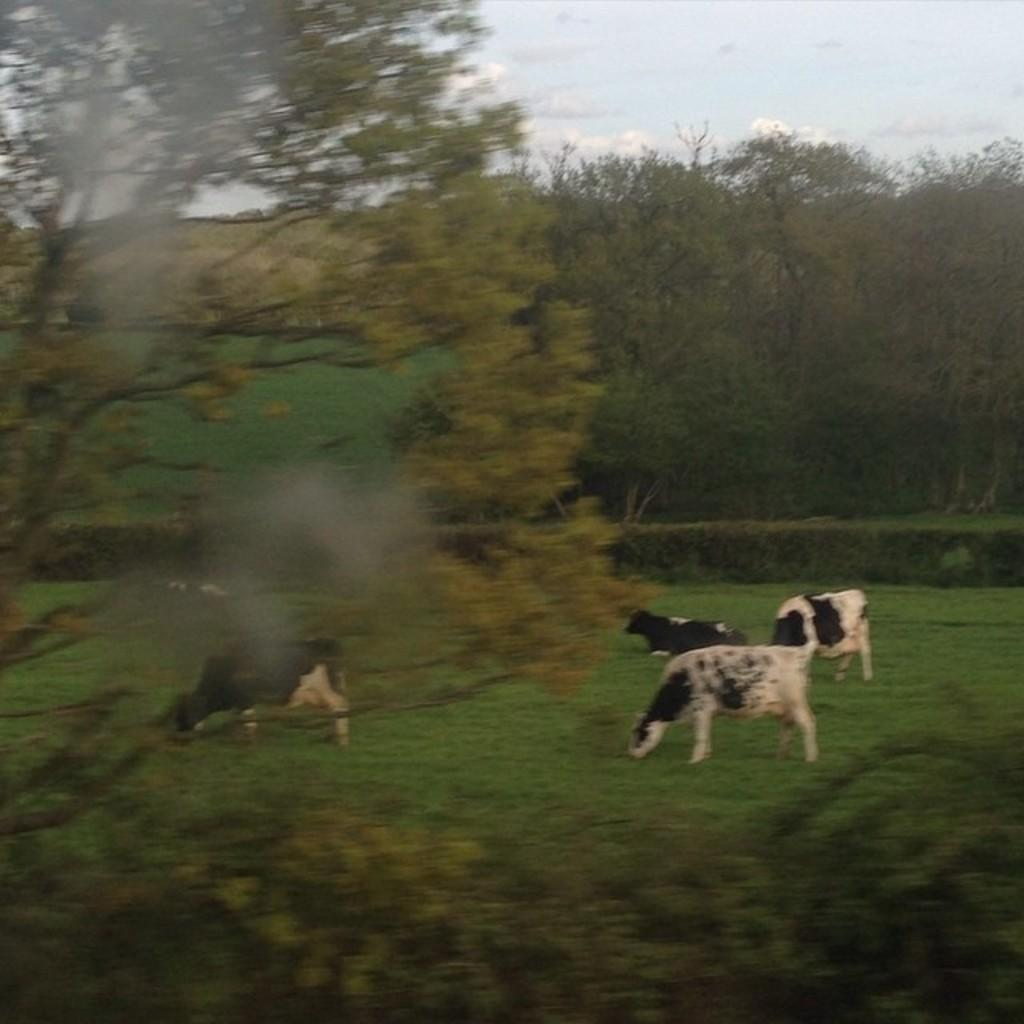What animals are present in the image? There are cows in the image. What type of vegetation is on the ground in the image? There is green grass on the ground in the image. What can be seen in the background of the image? There are trees in the background of the image. What is visible in the sky in the image? There are clouds in the sky in the image. What type of pies are being served to the cows in the image? There are no pies present in the image; it features cows on green grass with trees in the background and clouds in the sky. 